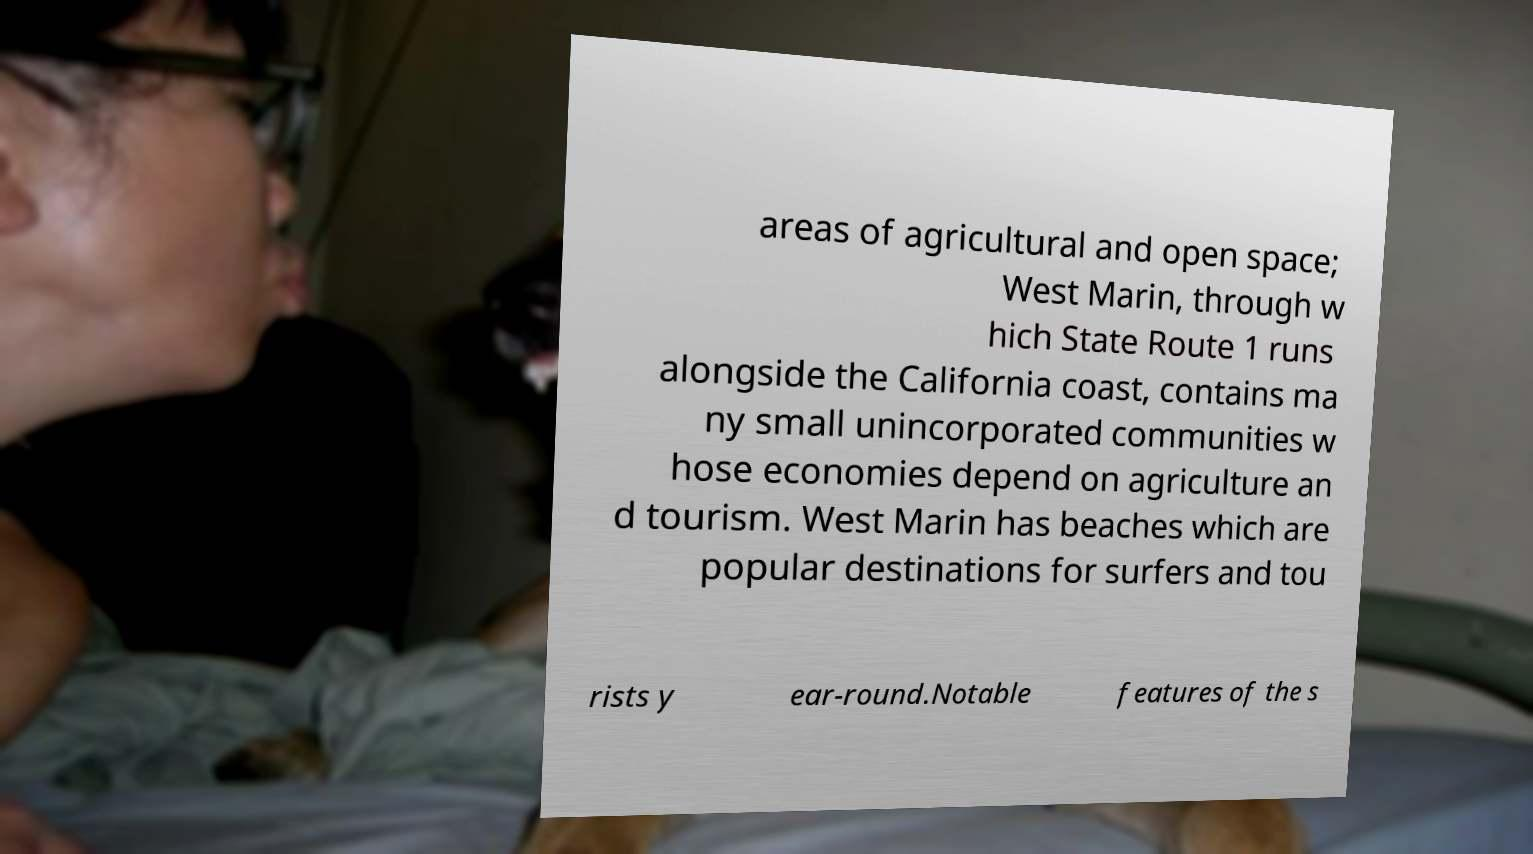What messages or text are displayed in this image? I need them in a readable, typed format. areas of agricultural and open space; West Marin, through w hich State Route 1 runs alongside the California coast, contains ma ny small unincorporated communities w hose economies depend on agriculture an d tourism. West Marin has beaches which are popular destinations for surfers and tou rists y ear-round.Notable features of the s 